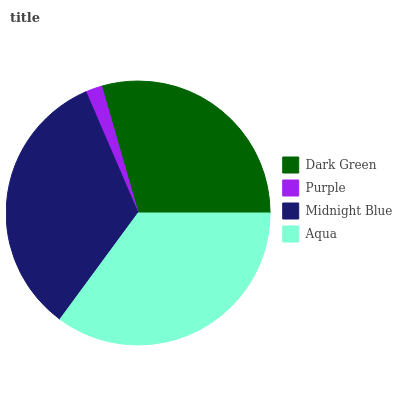Is Purple the minimum?
Answer yes or no. Yes. Is Aqua the maximum?
Answer yes or no. Yes. Is Midnight Blue the minimum?
Answer yes or no. No. Is Midnight Blue the maximum?
Answer yes or no. No. Is Midnight Blue greater than Purple?
Answer yes or no. Yes. Is Purple less than Midnight Blue?
Answer yes or no. Yes. Is Purple greater than Midnight Blue?
Answer yes or no. No. Is Midnight Blue less than Purple?
Answer yes or no. No. Is Midnight Blue the high median?
Answer yes or no. Yes. Is Dark Green the low median?
Answer yes or no. Yes. Is Purple the high median?
Answer yes or no. No. Is Midnight Blue the low median?
Answer yes or no. No. 